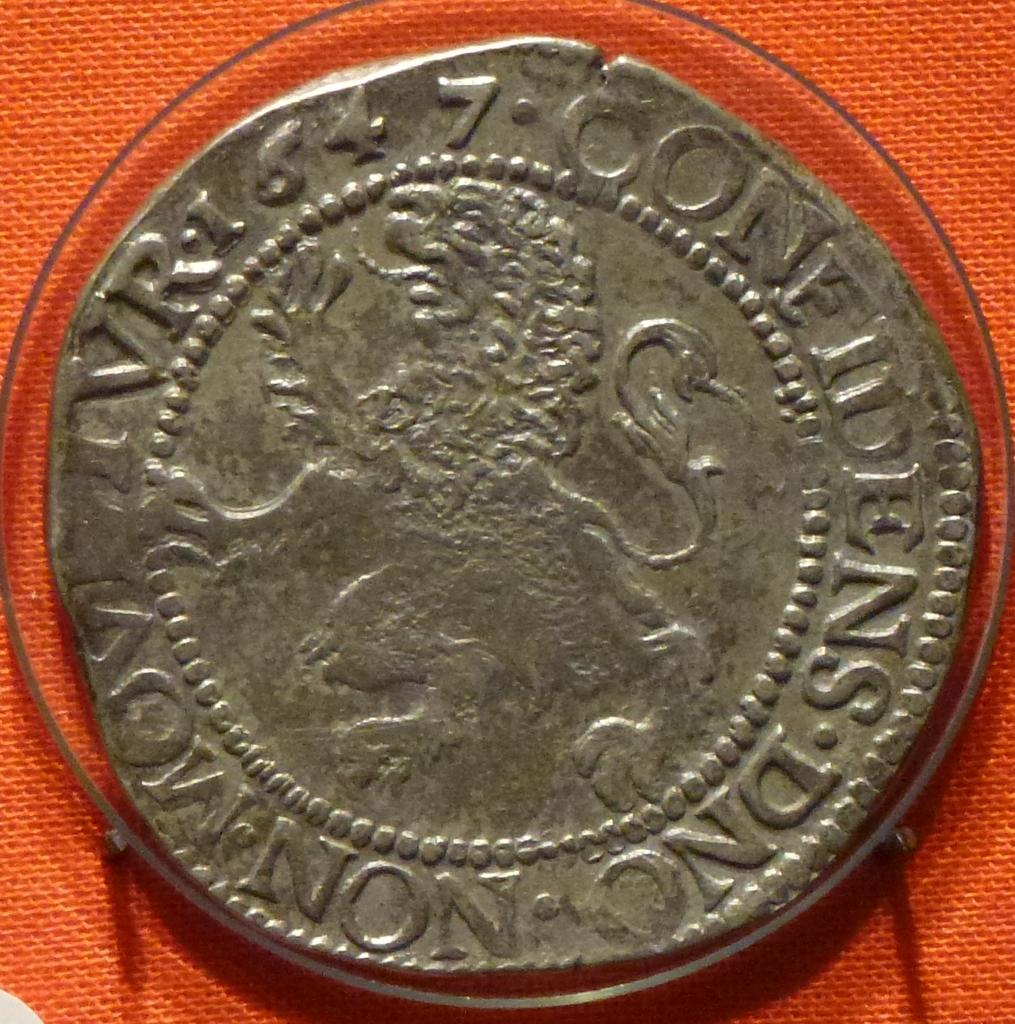<image>
Describe the image concisely. an old silver coin with a lion on it and words Confindens 